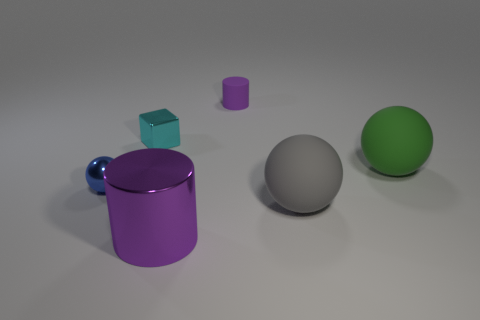How many other things are there of the same color as the small cylinder?
Keep it short and to the point. 1. Do the cylinder that is in front of the tiny cyan thing and the large gray thing have the same material?
Provide a succinct answer. No. Are there fewer metal things that are in front of the large gray sphere than tiny purple rubber cylinders to the right of the green matte sphere?
Your response must be concise. No. There is a purple cylinder that is the same size as the cyan block; what is it made of?
Your answer should be compact. Rubber. Are there fewer cyan blocks that are in front of the metallic ball than green shiny spheres?
Keep it short and to the point. No. There is a tiny blue thing on the left side of the tiny thing that is right of the shiny thing that is in front of the blue metal ball; what shape is it?
Ensure brevity in your answer.  Sphere. There is a cylinder that is in front of the gray rubber sphere; what size is it?
Give a very brief answer. Large. The other rubber object that is the same size as the cyan object is what shape?
Make the answer very short. Cylinder. How many objects are either small metallic balls or purple cylinders to the right of the large metal cylinder?
Your answer should be very brief. 2. How many blue metallic objects are on the right side of the purple thing in front of the metal thing to the left of the small cyan metallic thing?
Your answer should be compact. 0. 